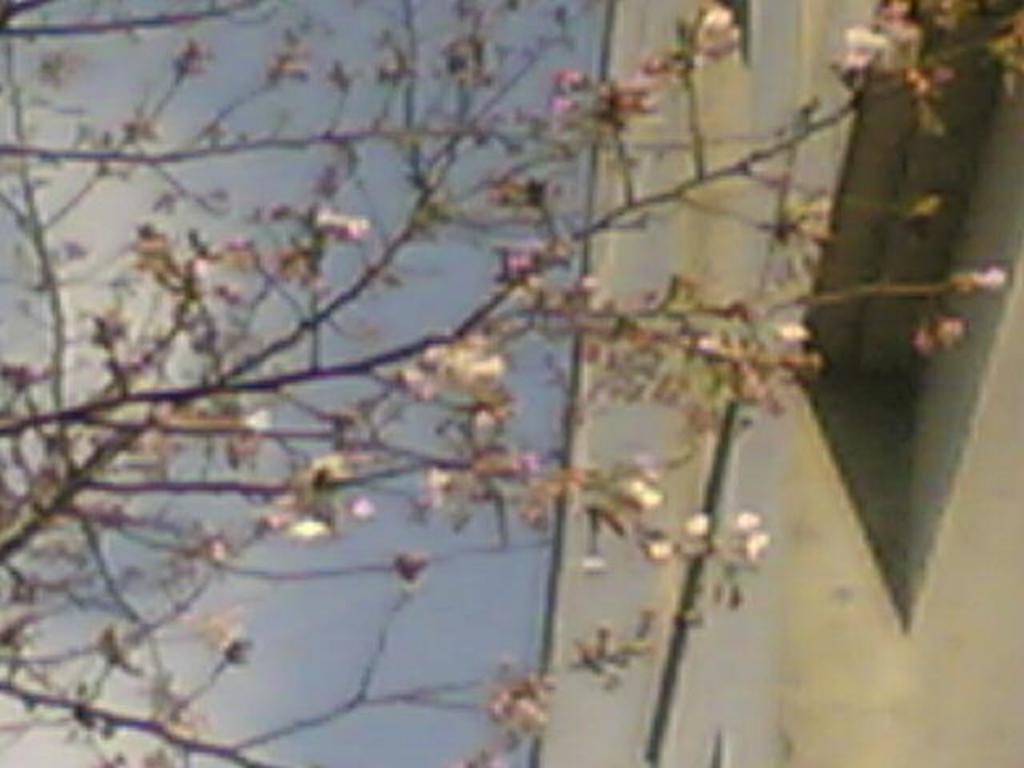What type of vegetation can be seen on a tree in the image? There are flowers on a tree in the image. What structure is located on the right side of the image? There is a building on the right side of the image. What is visible in the background of the image? The sky is visible in the background of the image. Where is the store located in the image? There is no store present in the image. What type of control can be seen in the image? There is no control present in the image. 